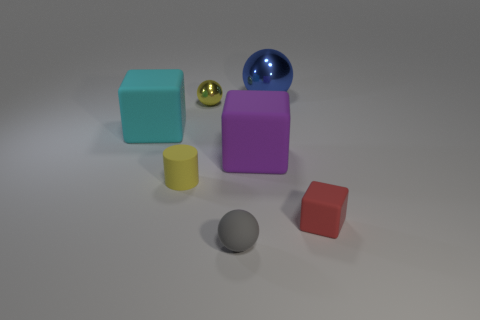There is a tiny rubber object behind the small red rubber block; what shape is it? The tiny rubber object located behind the small red rubber block appears to be a sphere, not a cylinder as previously mentioned. 